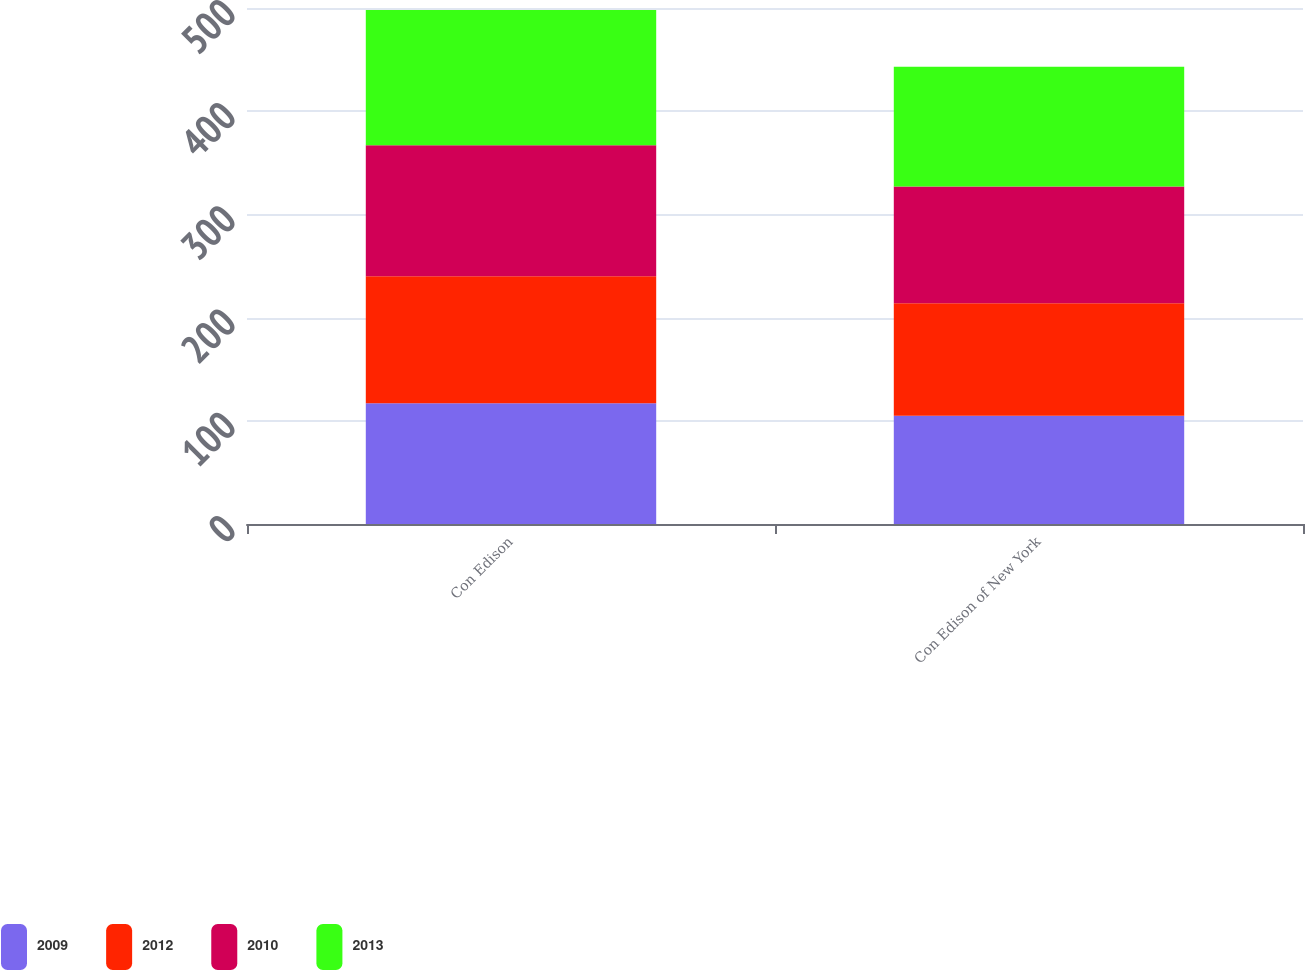Convert chart to OTSL. <chart><loc_0><loc_0><loc_500><loc_500><stacked_bar_chart><ecel><fcel>Con Edison<fcel>Con Edison of New York<nl><fcel>2009<fcel>117<fcel>105<nl><fcel>2012<fcel>123<fcel>109<nl><fcel>2010<fcel>127<fcel>113<nl><fcel>2013<fcel>131<fcel>116<nl></chart> 